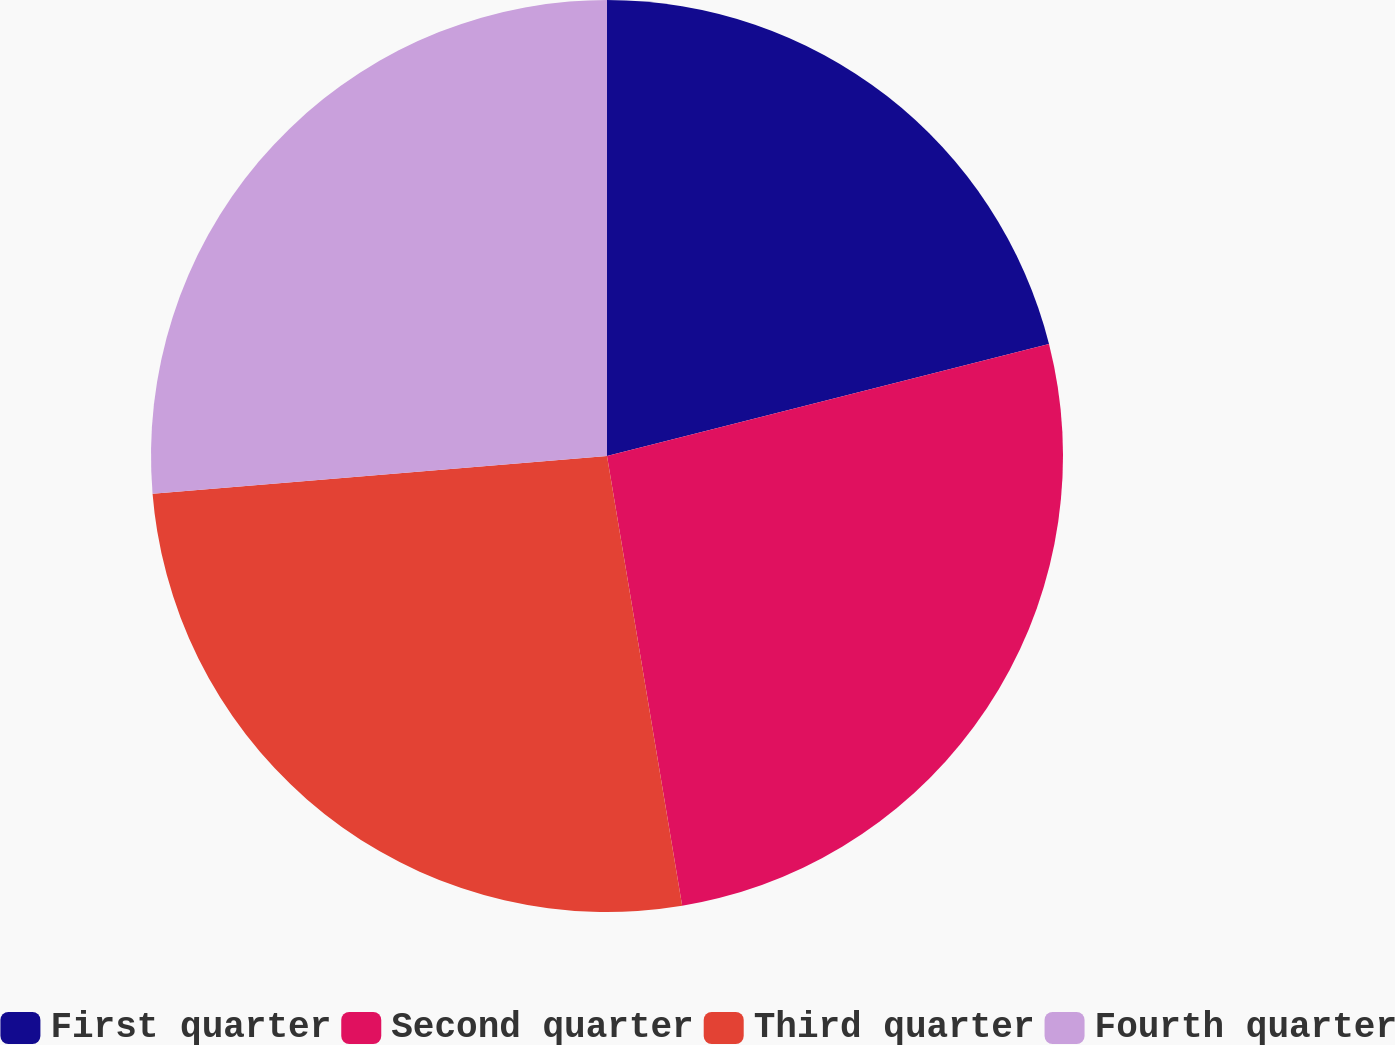Convert chart. <chart><loc_0><loc_0><loc_500><loc_500><pie_chart><fcel>First quarter<fcel>Second quarter<fcel>Third quarter<fcel>Fourth quarter<nl><fcel>21.05%<fcel>26.32%<fcel>26.32%<fcel>26.32%<nl></chart> 